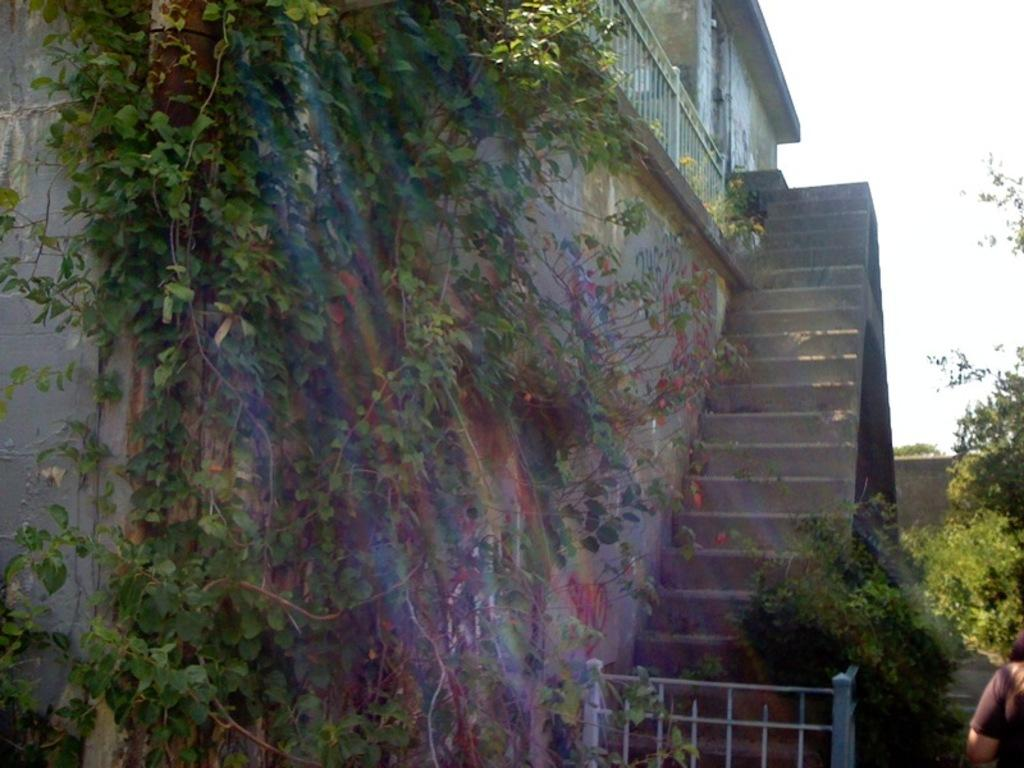What type of living organisms can be seen in the image? Plants are visible in the image. What architectural features can be seen in the image? Walls, stairs, railings, a building, and a gate are visible in the image. Can you describe the person in the image? There is a person in the image, but no specific details about their appearance or actions are provided. What part of the natural environment is visible in the image? The sky is visible in the top right corner of the image. What type of cloth is the beggar using to cover their face in the image? There is no beggar present in the image, and therefore no cloth covering their face. What offer is the person in the image making to the passerby? There is no indication of any offer being made in the image, as the person's actions are not described. 